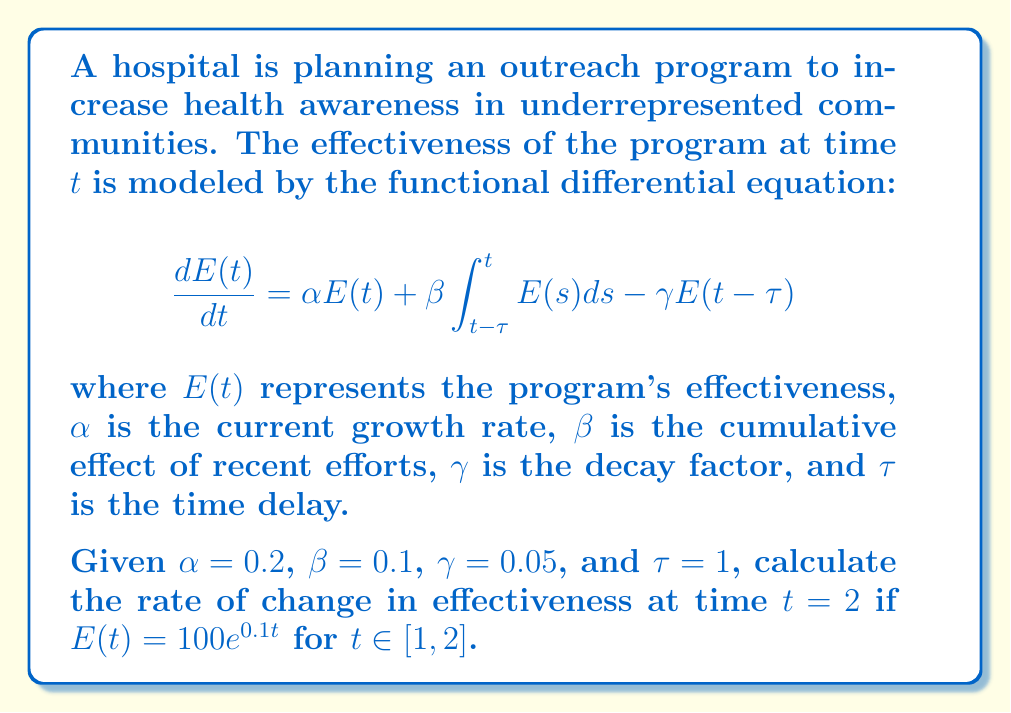Provide a solution to this math problem. To solve this problem, we need to follow these steps:

1) First, we need to calculate $E(2)$ and $E(1)$:
   $E(2) = 100e^{0.1(2)} = 100e^{0.2}$
   $E(1) = 100e^{0.1(1)} = 100e^{0.1}$

2) Next, we need to calculate the integral $\int_{t-\tau}^t E(s) ds$ for $t=2$:
   $$\int_{1}^2 100e^{0.1s} ds = \left.\frac{100}{0.1}e^{0.1s}\right|_{1}^2 = 1000(e^{0.2} - e^{0.1})$$

3) Now we can substitute these values into the differential equation:

   $$\frac{dE(2)}{dt} = 0.2(100e^{0.2}) + 0.1[1000(e^{0.2} - e^{0.1})] - 0.05(100e^{0.1})$$

4) Simplify:
   $$\frac{dE(2)}{dt} = 20e^{0.2} + 100(e^{0.2} - e^{0.1}) - 5e^{0.1}$$

5) Calculate the final result:
   $$\frac{dE(2)}{dt} = 20(1.2214) + 100(1.2214 - 1.1052) - 5(1.1052)$$
   $$= 24.428 + 11.62 - 5.526 = 30.522$$
Answer: The rate of change in effectiveness at time $t=2$ is approximately 30.522 units per time period. 